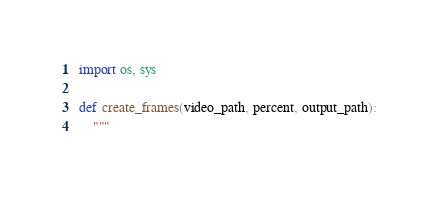Convert code to text. <code><loc_0><loc_0><loc_500><loc_500><_Python_>import os, sys

def create_frames(video_path, percent, output_path):
    """</code> 